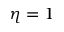Convert formula to latex. <formula><loc_0><loc_0><loc_500><loc_500>\eta = 1</formula> 